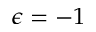<formula> <loc_0><loc_0><loc_500><loc_500>\epsilon = - 1</formula> 